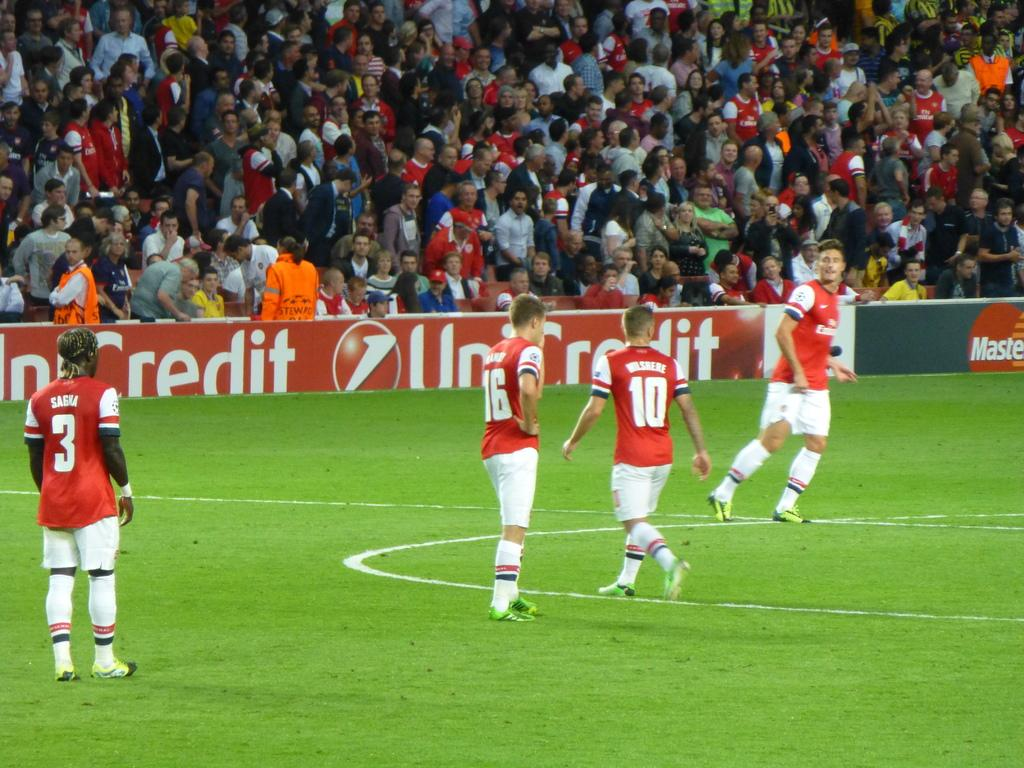<image>
Create a compact narrative representing the image presented. A group of soccer players in red jerseys are playing in front of a packed crowd at Mastercard Stadium. 